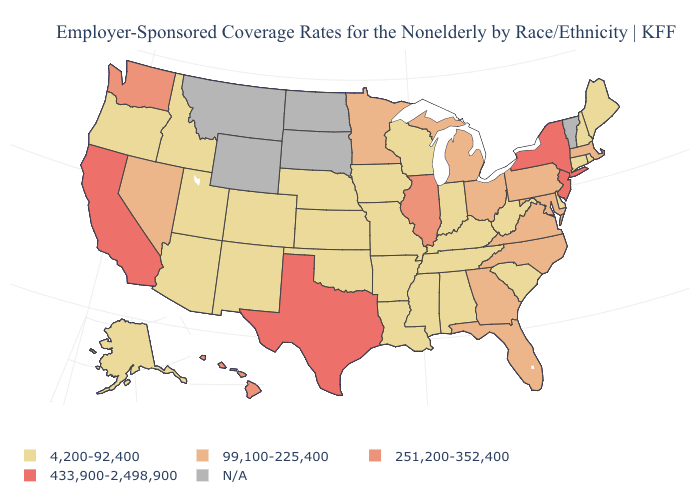What is the value of Iowa?
Quick response, please. 4,200-92,400. Name the states that have a value in the range 4,200-92,400?
Keep it brief. Alabama, Alaska, Arizona, Arkansas, Colorado, Connecticut, Delaware, Idaho, Indiana, Iowa, Kansas, Kentucky, Louisiana, Maine, Mississippi, Missouri, Nebraska, New Hampshire, New Mexico, Oklahoma, Oregon, Rhode Island, South Carolina, Tennessee, Utah, West Virginia, Wisconsin. How many symbols are there in the legend?
Answer briefly. 5. How many symbols are there in the legend?
Short answer required. 5. What is the value of New York?
Keep it brief. 433,900-2,498,900. Name the states that have a value in the range 433,900-2,498,900?
Short answer required. California, New Jersey, New York, Texas. Which states hav the highest value in the South?
Quick response, please. Texas. How many symbols are there in the legend?
Write a very short answer. 5. What is the lowest value in the USA?
Short answer required. 4,200-92,400. What is the value of Arkansas?
Write a very short answer. 4,200-92,400. Which states have the highest value in the USA?
Quick response, please. California, New Jersey, New York, Texas. Does Missouri have the highest value in the USA?
Concise answer only. No. 